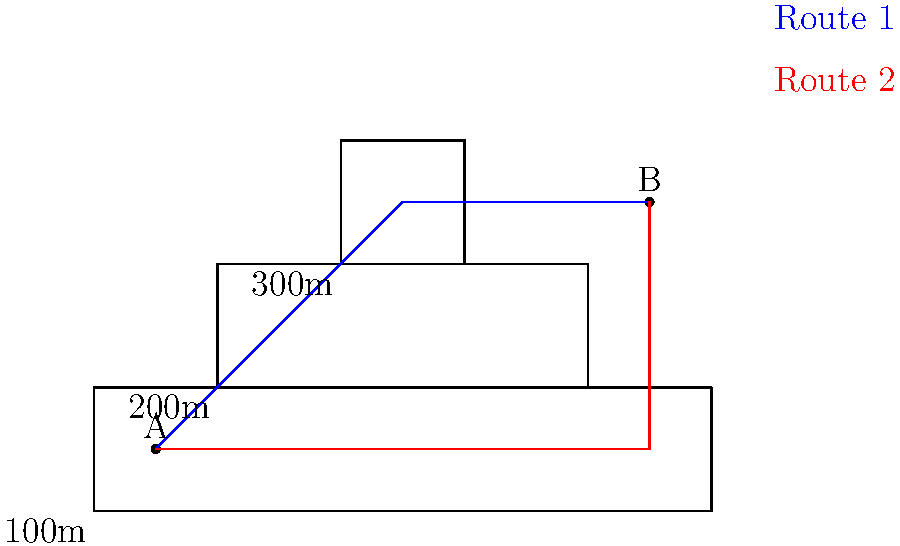Based on the topographical map provided, which route (1 or 2) would be the most efficient for troop movement from point A to point B, considering both distance and elevation changes? To determine the most efficient route for troop movement, we need to consider both distance and elevation changes:

1. Analyze Route 1 (blue):
   - Travels diagonally across the map
   - Crosses all three elevation levels (100m, 200m, 300m)
   - Total elevation gain: approximately 200m
   - Shorter distance than Route 2

2. Analyze Route 2 (red):
   - Follows the contour line at 100m elevation for most of the journey
   - Only climbs from 100m to 200m near the end
   - Total elevation gain: approximately 100m
   - Slightly longer distance than Route 1

3. Consider the trade-off:
   - Route 1 is shorter but requires more elevation changes
   - Route 2 is slightly longer but has less elevation gain

4. Military considerations:
   - Energy conservation is crucial for troop movement
   - Consistent elevation is generally preferred over frequent changes
   - The extra distance of Route 2 is likely offset by the reduced elevation gain

5. Conclusion:
   Route 2 (red) is the most efficient for troop movement because it minimizes elevation changes, which conserves energy and maintains a more consistent pace, despite being slightly longer in distance.
Answer: Route 2 (red) 